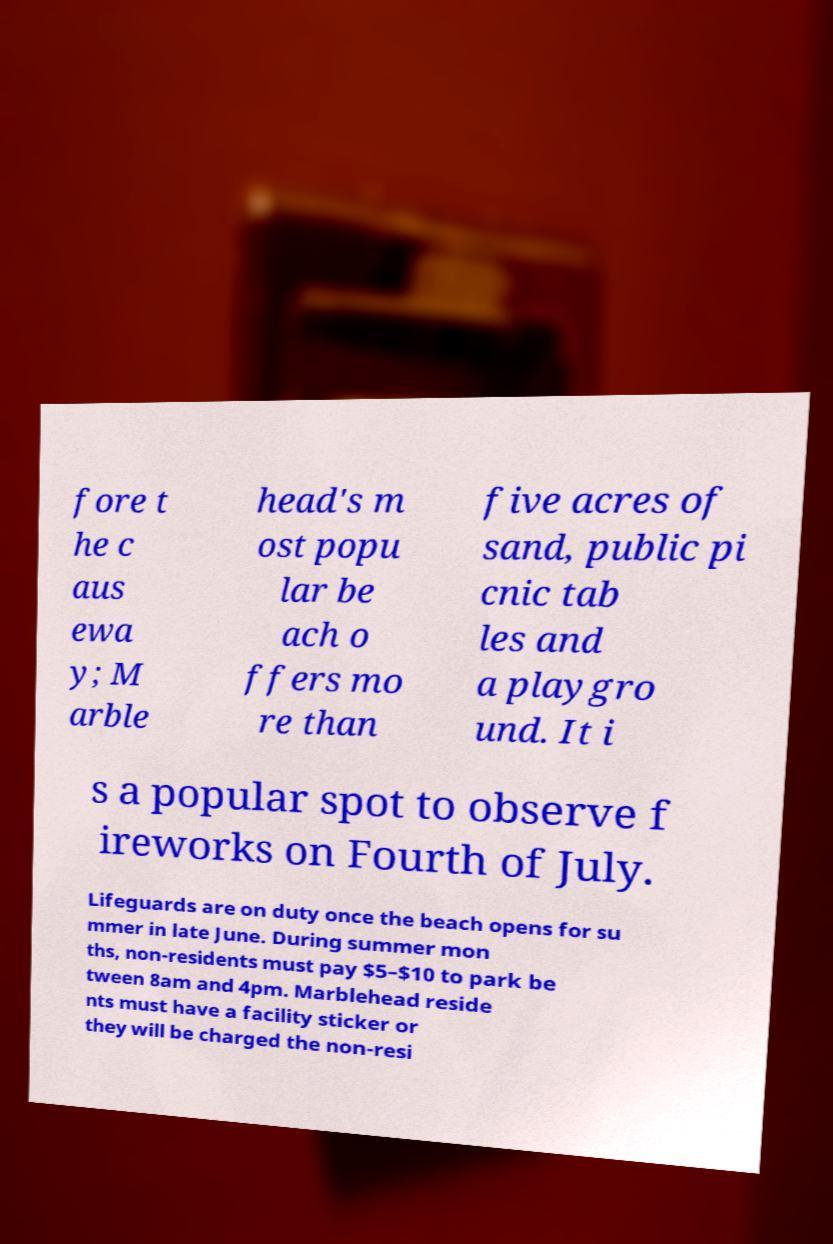Please read and relay the text visible in this image. What does it say? fore t he c aus ewa y; M arble head's m ost popu lar be ach o ffers mo re than five acres of sand, public pi cnic tab les and a playgro und. It i s a popular spot to observe f ireworks on Fourth of July. Lifeguards are on duty once the beach opens for su mmer in late June. During summer mon ths, non-residents must pay $5–$10 to park be tween 8am and 4pm. Marblehead reside nts must have a facility sticker or they will be charged the non-resi 